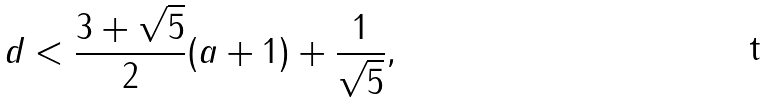Convert formula to latex. <formula><loc_0><loc_0><loc_500><loc_500>d < \frac { 3 + \sqrt { 5 } } { 2 } ( a + 1 ) + \frac { 1 } { \sqrt { 5 } } ,</formula> 